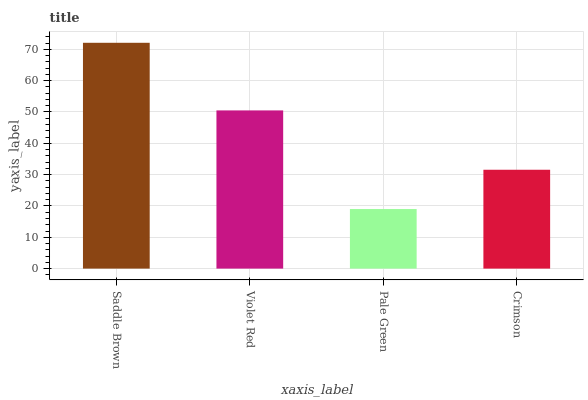Is Pale Green the minimum?
Answer yes or no. Yes. Is Saddle Brown the maximum?
Answer yes or no. Yes. Is Violet Red the minimum?
Answer yes or no. No. Is Violet Red the maximum?
Answer yes or no. No. Is Saddle Brown greater than Violet Red?
Answer yes or no. Yes. Is Violet Red less than Saddle Brown?
Answer yes or no. Yes. Is Violet Red greater than Saddle Brown?
Answer yes or no. No. Is Saddle Brown less than Violet Red?
Answer yes or no. No. Is Violet Red the high median?
Answer yes or no. Yes. Is Crimson the low median?
Answer yes or no. Yes. Is Pale Green the high median?
Answer yes or no. No. Is Pale Green the low median?
Answer yes or no. No. 